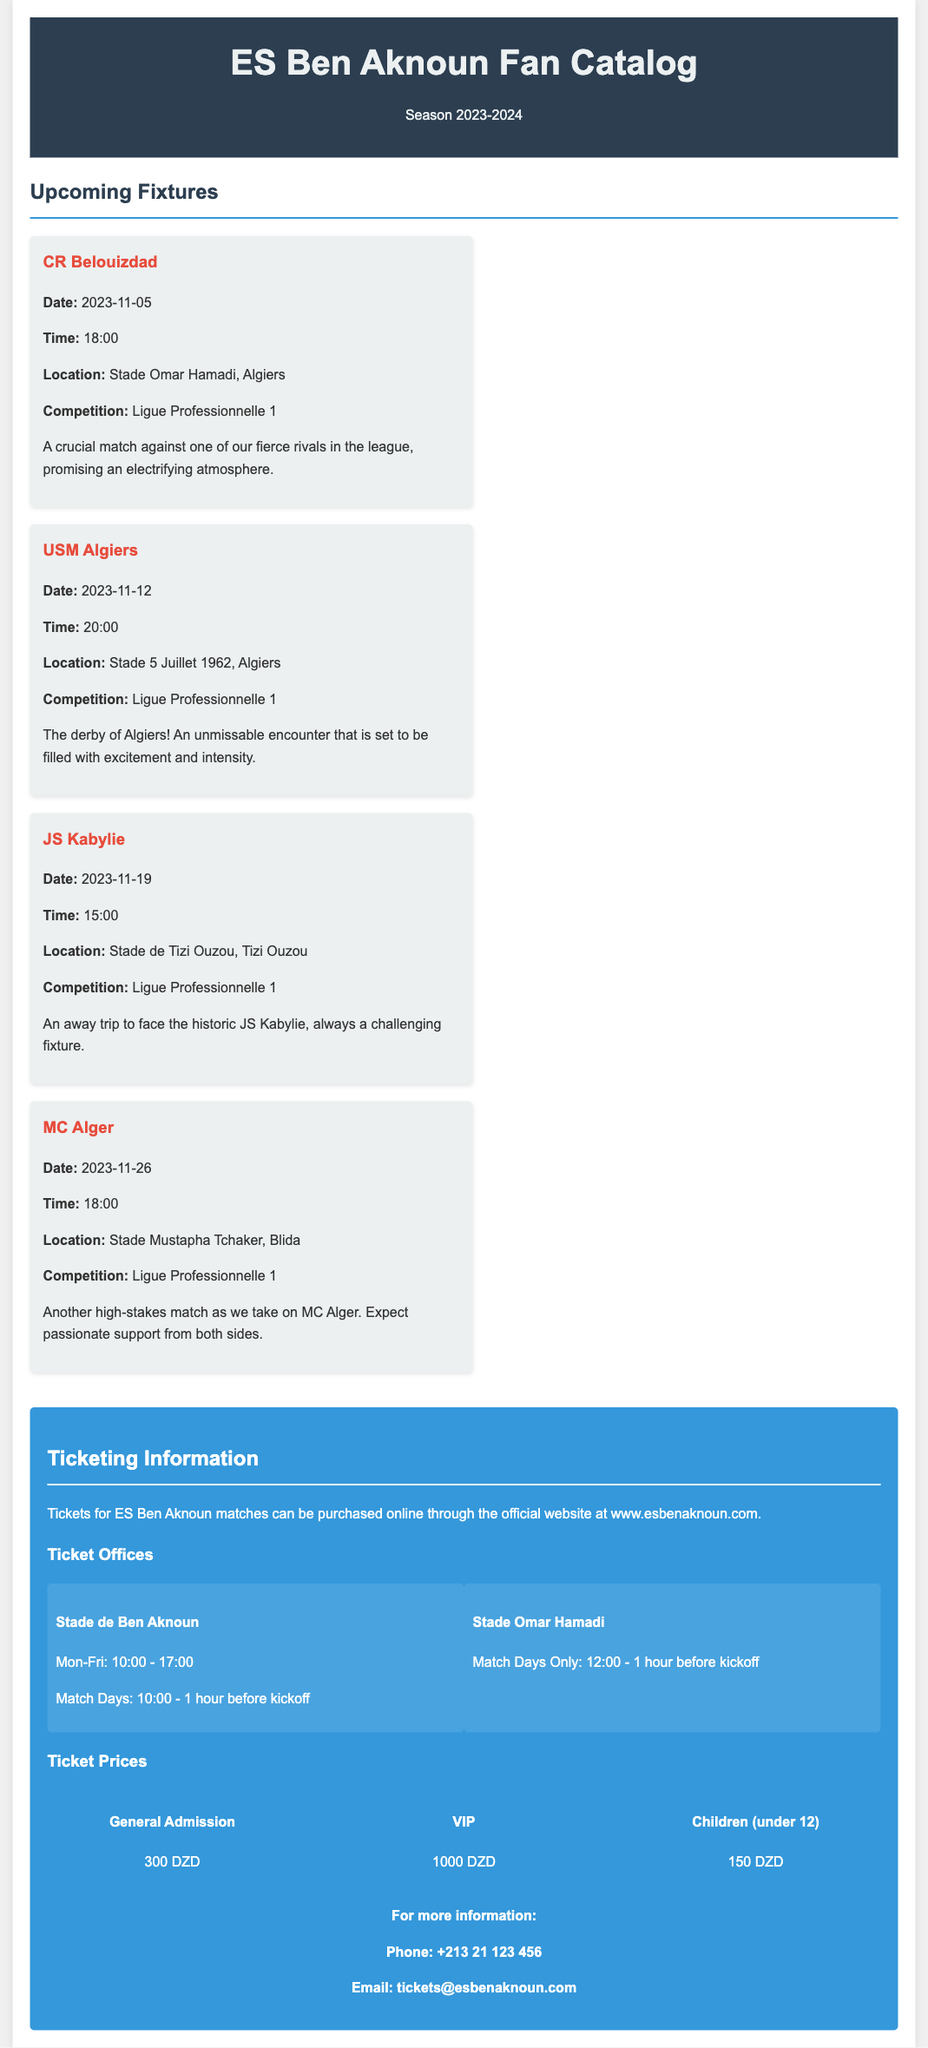what is the date of the match against CR Belouizdad? The match against CR Belouizdad is scheduled for November 5, 2023.
Answer: November 5, 2023 what time does the match against USM Algiers start? The match against USM Algiers starts at 20:00.
Answer: 20:00 where is the match against JS Kabylie taking place? The match against JS Kabylie is taking place at Stade de Tizi Ouzou, Tizi Ouzou.
Answer: Stade de Tizi Ouzou, Tizi Ouzou how much is the ticket price for general admission? The ticket price for general admission is listed as 300 DZD.
Answer: 300 DZD when are tickets available at Stade Omar Hamadi? Tickets at Stade Omar Hamadi are available only on match days from 12:00 until one hour before kickoff.
Answer: Match Days Only: 12:00 - 1 hour before kickoff which match is considered the derby of Algiers? The match against USM Algiers is considered the derby of Algiers.
Answer: USM Algiers what is the VIP ticket price? The VIP ticket price is listed as 1000 DZD.
Answer: 1000 DZD what should a fan do to purchase tickets online? Fans can purchase tickets online through the official website.
Answer: www.esbenaknoun.com how can someone contact for more ticket information? For more information, fans can call the provided phone number or email the address given in the document.
Answer: Phone: +213 21 123 456 / Email: tickets@esbenaknoun.com 